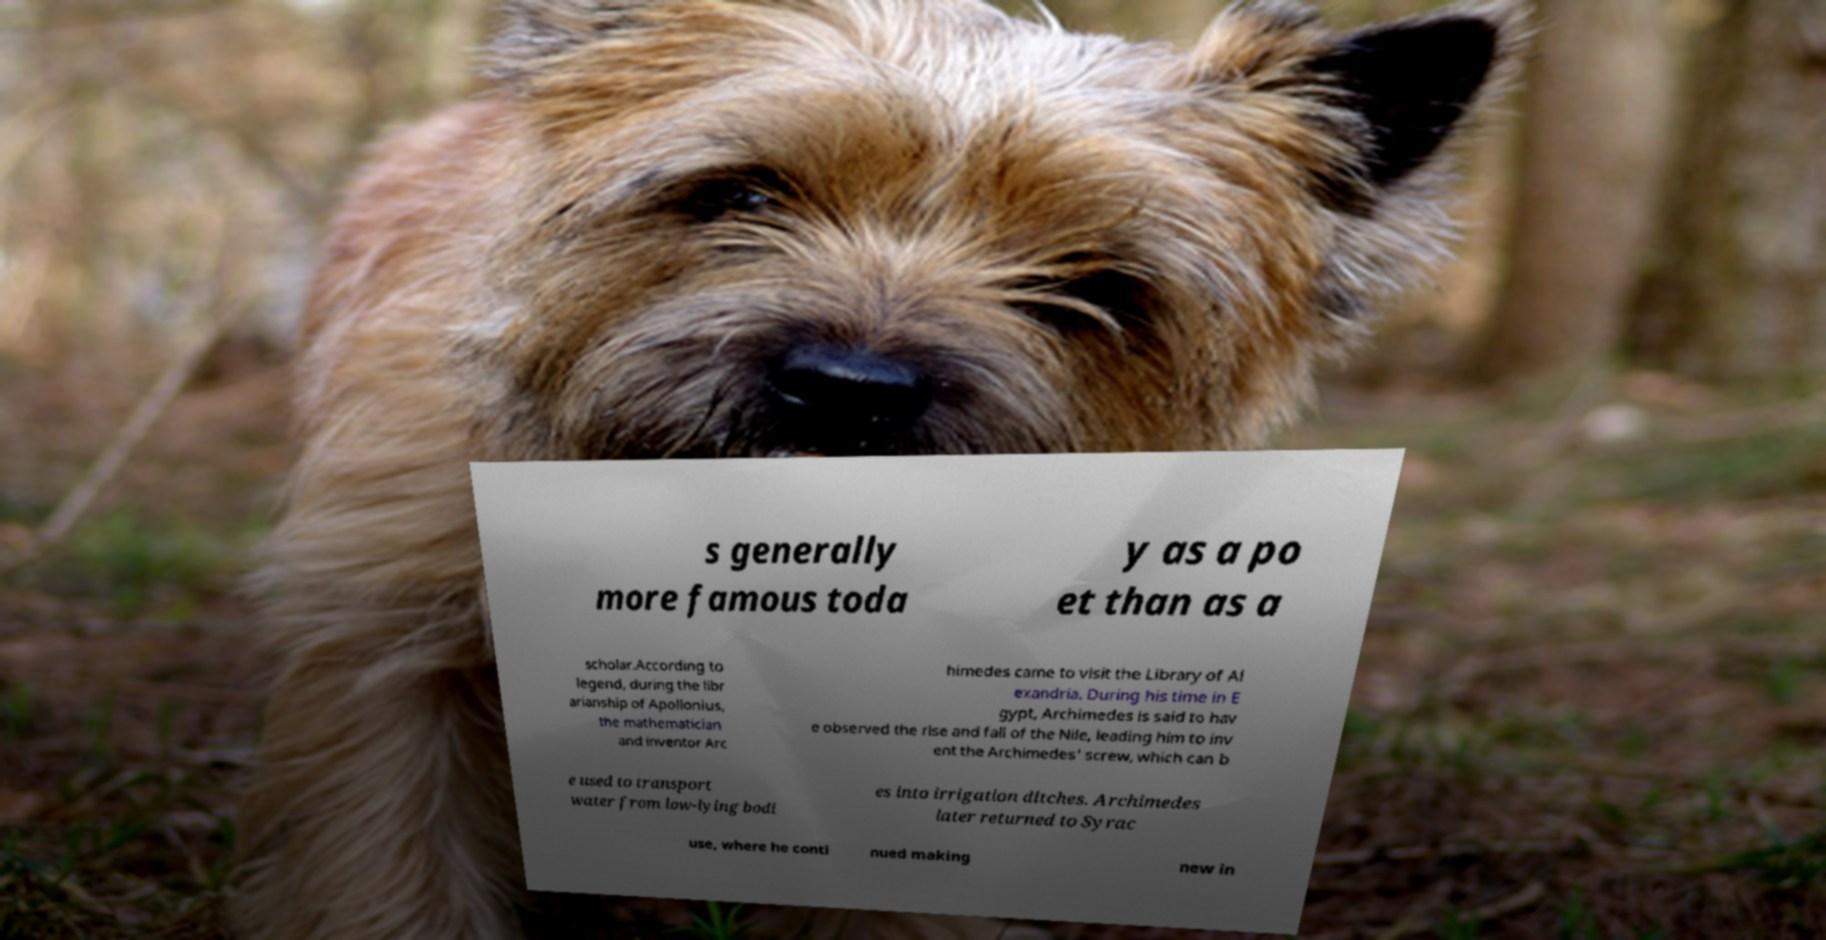There's text embedded in this image that I need extracted. Can you transcribe it verbatim? s generally more famous toda y as a po et than as a scholar.According to legend, during the libr arianship of Apollonius, the mathematician and inventor Arc himedes came to visit the Library of Al exandria. During his time in E gypt, Archimedes is said to hav e observed the rise and fall of the Nile, leading him to inv ent the Archimedes' screw, which can b e used to transport water from low-lying bodi es into irrigation ditches. Archimedes later returned to Syrac use, where he conti nued making new in 